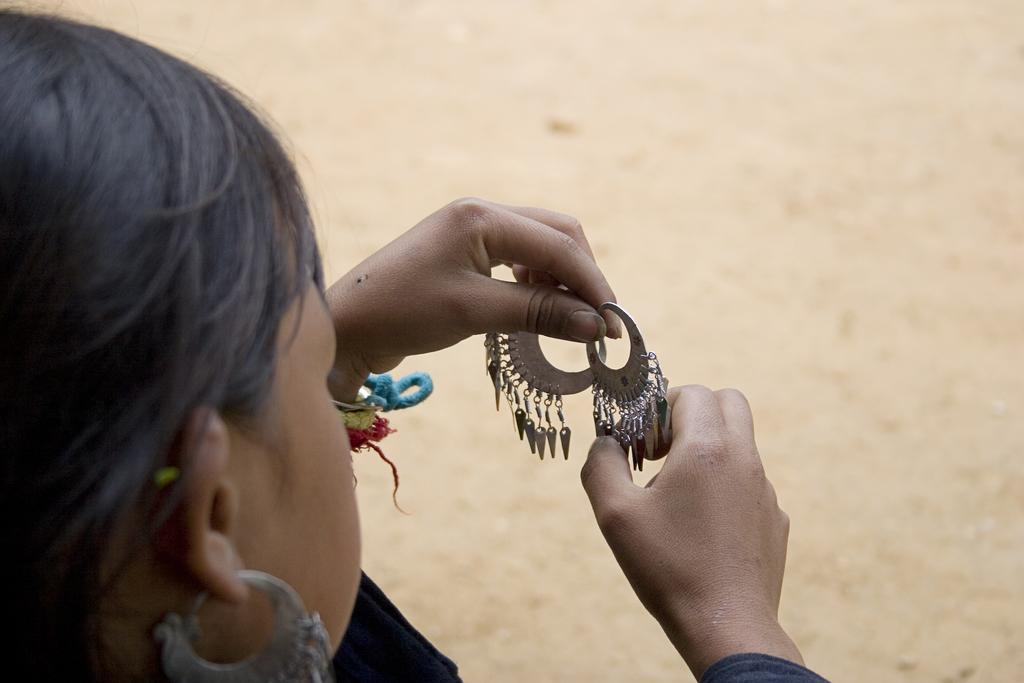Who is present in the image? There is a woman in the picture. What is the woman holding in the image? The woman is holding earrings. What type of plant is growing in the sink in the image? There is no sink or plant present in the image; it features a woman holding earrings. 